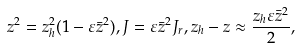Convert formula to latex. <formula><loc_0><loc_0><loc_500><loc_500>z ^ { 2 } = z ^ { 2 } _ { h } ( 1 - \varepsilon \bar { z } ^ { 2 } ) , J = \varepsilon \bar { z } ^ { 2 } J _ { r } , z _ { h } - z \approx \frac { z _ { h } \varepsilon \bar { z } ^ { 2 } } { 2 } ,</formula> 